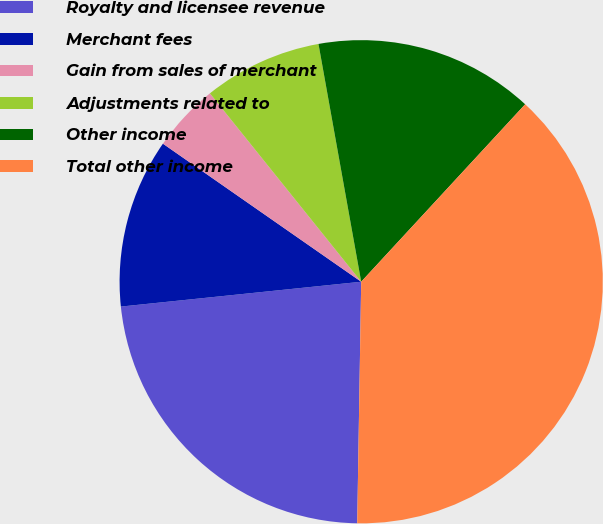<chart> <loc_0><loc_0><loc_500><loc_500><pie_chart><fcel>Royalty and licensee revenue<fcel>Merchant fees<fcel>Gain from sales of merchant<fcel>Adjustments related to<fcel>Other income<fcel>Total other income<nl><fcel>23.1%<fcel>11.32%<fcel>4.55%<fcel>7.94%<fcel>14.7%<fcel>38.39%<nl></chart> 